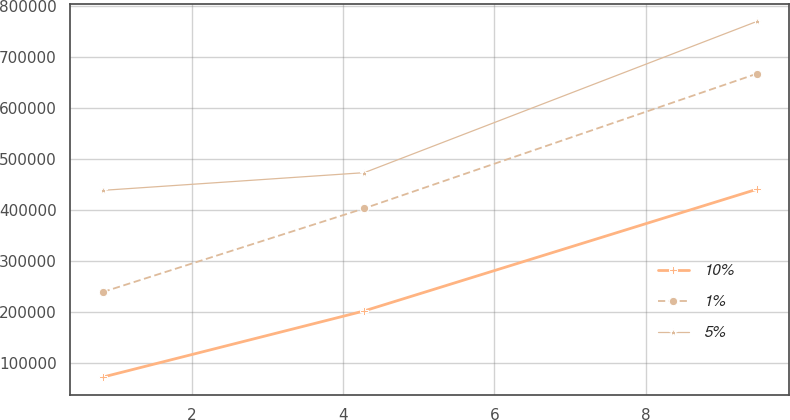<chart> <loc_0><loc_0><loc_500><loc_500><line_chart><ecel><fcel>10%<fcel>1%<fcel>5%<nl><fcel>0.82<fcel>71964<fcel>239004<fcel>438761<nl><fcel>4.28<fcel>202044<fcel>403411<fcel>473527<nl><fcel>9.47<fcel>440832<fcel>667792<fcel>770440<nl></chart> 